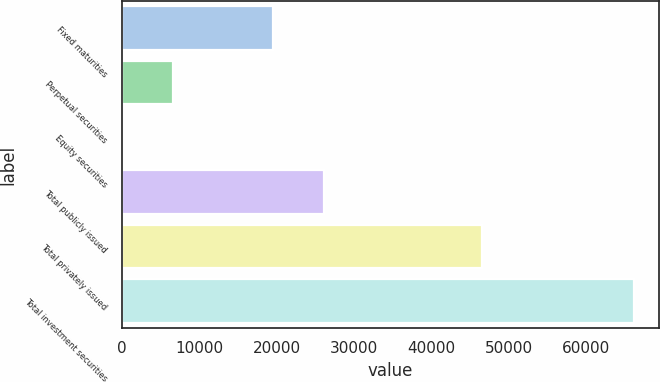Convert chart. <chart><loc_0><loc_0><loc_500><loc_500><bar_chart><fcel>Fixed maturities<fcel>Perpetual securities<fcel>Equity securities<fcel>Total publicly issued<fcel>Total privately issued<fcel>Total investment securities<nl><fcel>19525<fcel>6633.2<fcel>18<fcel>26140.2<fcel>46523<fcel>66170<nl></chart> 